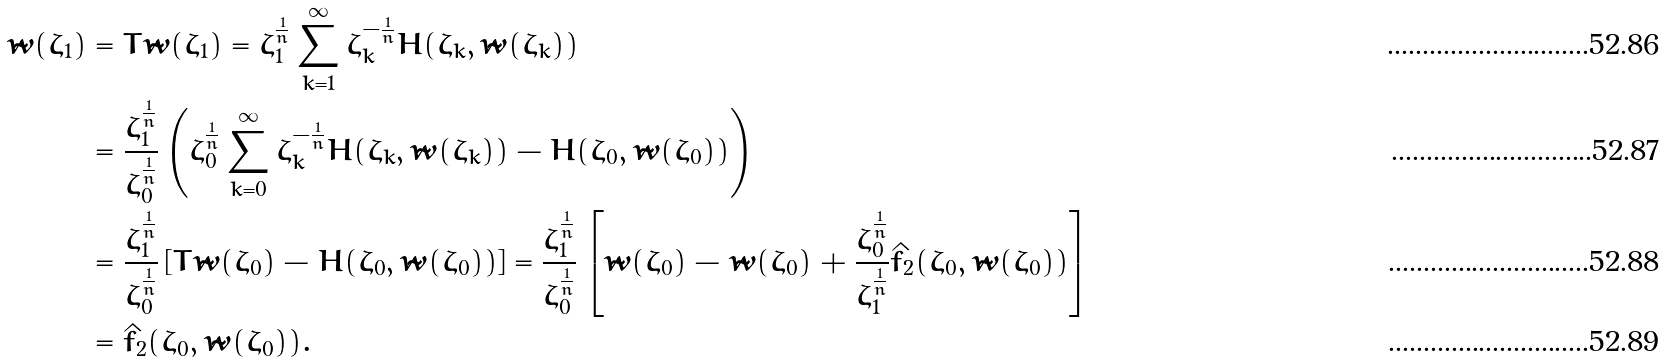Convert formula to latex. <formula><loc_0><loc_0><loc_500><loc_500>\tilde { w } ( \zeta _ { 1 } ) & = T \tilde { w } ( \zeta _ { 1 } ) = \zeta _ { 1 } ^ { \frac { 1 } { n } } \sum _ { k = 1 } ^ { \infty } \zeta _ { k } ^ { - \frac { 1 } { n } } H ( \zeta _ { k } , \tilde { w } ( \zeta _ { k } ) ) \\ & = \frac { \zeta _ { 1 } ^ { \frac { 1 } { n } } } { \zeta _ { 0 } ^ { \frac { 1 } { n } } } \left ( \zeta _ { 0 } ^ { \frac { 1 } { n } } \sum _ { k = 0 } ^ { \infty } \zeta _ { k } ^ { - \frac { 1 } { n } } H ( \zeta _ { k } , \tilde { w } ( \zeta _ { k } ) ) - H ( \zeta _ { 0 } , \tilde { w } ( \zeta _ { 0 } ) ) \right ) \\ & = \frac { \zeta _ { 1 } ^ { \frac { 1 } { n } } } { \zeta _ { 0 } ^ { \frac { 1 } { n } } } \left [ T \tilde { w } ( \zeta _ { 0 } ) - H ( \zeta _ { 0 } , \tilde { w } ( \zeta _ { 0 } ) ) \right ] = \frac { \zeta _ { 1 } ^ { \frac { 1 } { n } } } { \zeta _ { 0 } ^ { \frac { 1 } { n } } } \left [ \tilde { w } ( \zeta _ { 0 } ) - \tilde { w } ( \zeta _ { 0 } ) + \frac { \zeta _ { 0 } ^ { \frac { 1 } { n } } } { \zeta _ { 1 } ^ { \frac { 1 } { n } } } \hat { f } _ { 2 } ( \zeta _ { 0 } , \tilde { w } ( \zeta _ { 0 } ) ) \right ] \\ & = \hat { f } _ { 2 } ( \zeta _ { 0 } , \tilde { w } ( \zeta _ { 0 } ) ) .</formula> 